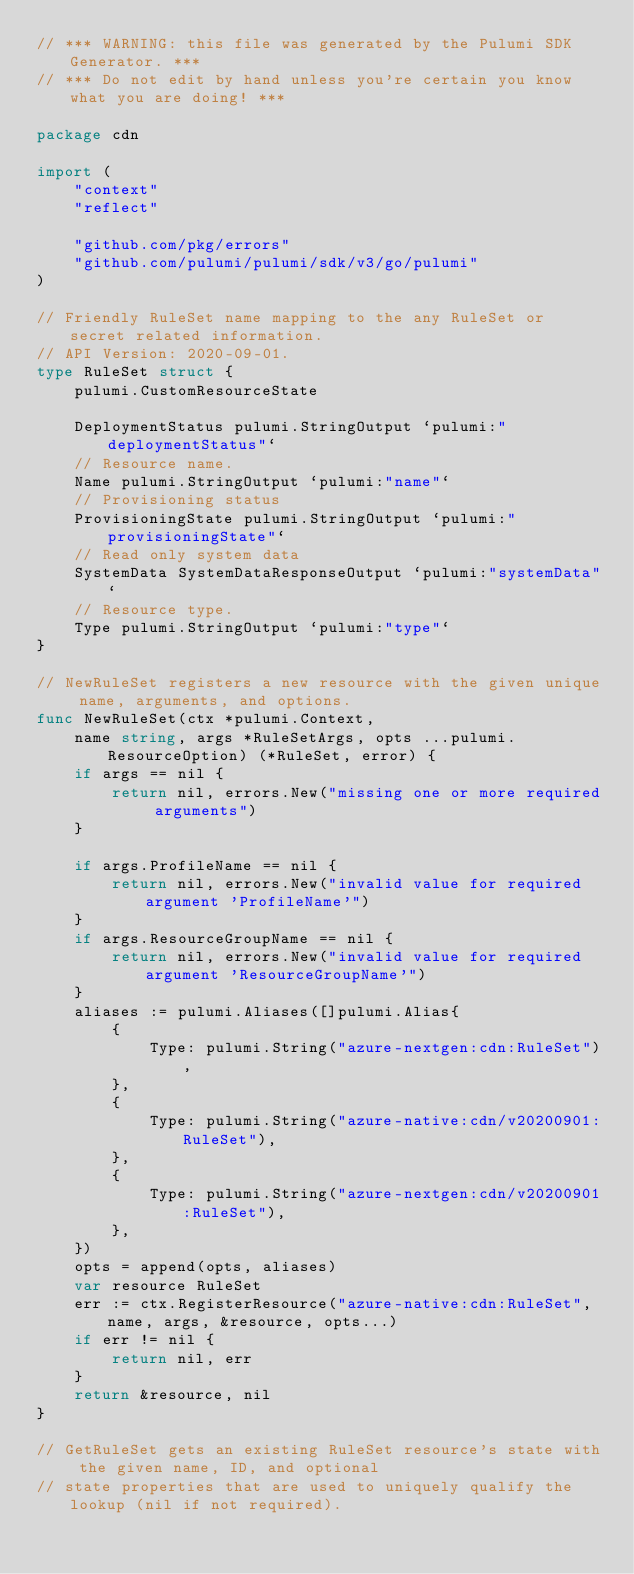<code> <loc_0><loc_0><loc_500><loc_500><_Go_>// *** WARNING: this file was generated by the Pulumi SDK Generator. ***
// *** Do not edit by hand unless you're certain you know what you are doing! ***

package cdn

import (
	"context"
	"reflect"

	"github.com/pkg/errors"
	"github.com/pulumi/pulumi/sdk/v3/go/pulumi"
)

// Friendly RuleSet name mapping to the any RuleSet or secret related information.
// API Version: 2020-09-01.
type RuleSet struct {
	pulumi.CustomResourceState

	DeploymentStatus pulumi.StringOutput `pulumi:"deploymentStatus"`
	// Resource name.
	Name pulumi.StringOutput `pulumi:"name"`
	// Provisioning status
	ProvisioningState pulumi.StringOutput `pulumi:"provisioningState"`
	// Read only system data
	SystemData SystemDataResponseOutput `pulumi:"systemData"`
	// Resource type.
	Type pulumi.StringOutput `pulumi:"type"`
}

// NewRuleSet registers a new resource with the given unique name, arguments, and options.
func NewRuleSet(ctx *pulumi.Context,
	name string, args *RuleSetArgs, opts ...pulumi.ResourceOption) (*RuleSet, error) {
	if args == nil {
		return nil, errors.New("missing one or more required arguments")
	}

	if args.ProfileName == nil {
		return nil, errors.New("invalid value for required argument 'ProfileName'")
	}
	if args.ResourceGroupName == nil {
		return nil, errors.New("invalid value for required argument 'ResourceGroupName'")
	}
	aliases := pulumi.Aliases([]pulumi.Alias{
		{
			Type: pulumi.String("azure-nextgen:cdn:RuleSet"),
		},
		{
			Type: pulumi.String("azure-native:cdn/v20200901:RuleSet"),
		},
		{
			Type: pulumi.String("azure-nextgen:cdn/v20200901:RuleSet"),
		},
	})
	opts = append(opts, aliases)
	var resource RuleSet
	err := ctx.RegisterResource("azure-native:cdn:RuleSet", name, args, &resource, opts...)
	if err != nil {
		return nil, err
	}
	return &resource, nil
}

// GetRuleSet gets an existing RuleSet resource's state with the given name, ID, and optional
// state properties that are used to uniquely qualify the lookup (nil if not required).</code> 